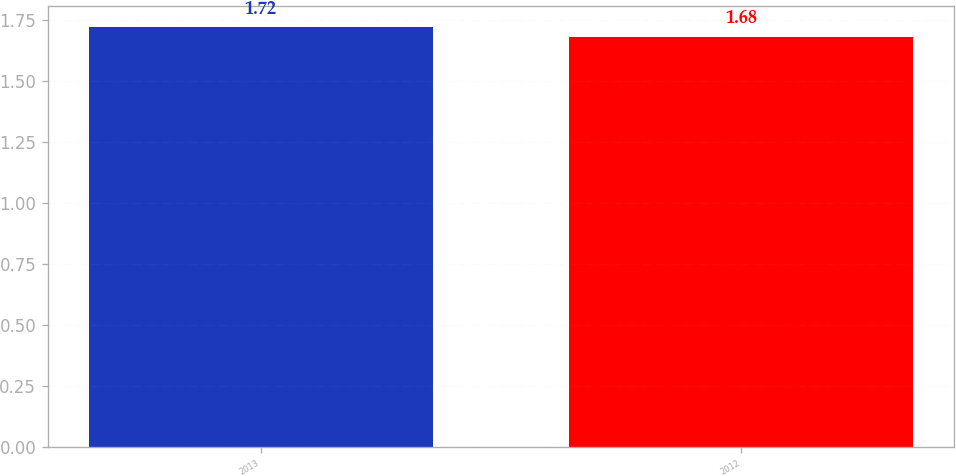<chart> <loc_0><loc_0><loc_500><loc_500><bar_chart><fcel>2013<fcel>2012<nl><fcel>1.72<fcel>1.68<nl></chart> 